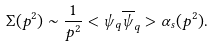<formula> <loc_0><loc_0><loc_500><loc_500>\Sigma ( p ^ { 2 } ) \sim \frac { 1 } { p ^ { 2 } } < \psi _ { q } \overline { \psi } _ { q } > \alpha _ { s } ( p ^ { 2 } ) .</formula> 